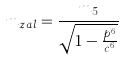Convert formula to latex. <formula><loc_0><loc_0><loc_500><loc_500>m _ { z a l } = \frac { m _ { 5 } } { \sqrt { 1 - \frac { p ^ { 6 } } { c ^ { 6 } } } }</formula> 